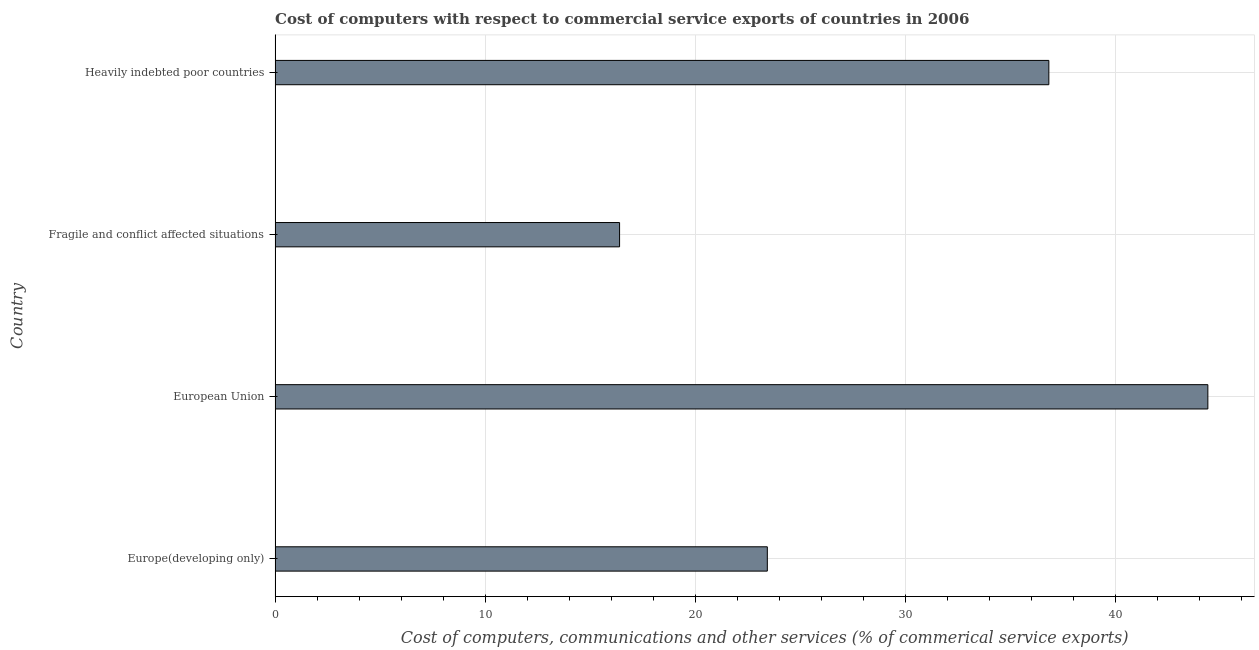What is the title of the graph?
Provide a short and direct response. Cost of computers with respect to commercial service exports of countries in 2006. What is the label or title of the X-axis?
Provide a succinct answer. Cost of computers, communications and other services (% of commerical service exports). What is the cost of communications in Fragile and conflict affected situations?
Offer a terse response. 16.39. Across all countries, what is the maximum cost of communications?
Offer a terse response. 44.38. Across all countries, what is the minimum cost of communications?
Offer a very short reply. 16.39. In which country was the  computer and other services minimum?
Make the answer very short. Fragile and conflict affected situations. What is the sum of the cost of communications?
Give a very brief answer. 121. What is the difference between the cost of communications in European Union and Fragile and conflict affected situations?
Keep it short and to the point. 27.99. What is the average  computer and other services per country?
Provide a short and direct response. 30.25. What is the median cost of communications?
Offer a terse response. 30.12. What is the ratio of the  computer and other services in Europe(developing only) to that in Fragile and conflict affected situations?
Offer a terse response. 1.43. Is the  computer and other services in European Union less than that in Heavily indebted poor countries?
Ensure brevity in your answer.  No. What is the difference between the highest and the second highest cost of communications?
Keep it short and to the point. 7.57. What is the difference between the highest and the lowest  computer and other services?
Ensure brevity in your answer.  27.99. In how many countries, is the cost of communications greater than the average cost of communications taken over all countries?
Provide a succinct answer. 2. How many bars are there?
Your answer should be compact. 4. Are all the bars in the graph horizontal?
Offer a terse response. Yes. What is the Cost of computers, communications and other services (% of commerical service exports) of Europe(developing only)?
Ensure brevity in your answer.  23.42. What is the Cost of computers, communications and other services (% of commerical service exports) of European Union?
Your response must be concise. 44.38. What is the Cost of computers, communications and other services (% of commerical service exports) of Fragile and conflict affected situations?
Give a very brief answer. 16.39. What is the Cost of computers, communications and other services (% of commerical service exports) of Heavily indebted poor countries?
Offer a very short reply. 36.81. What is the difference between the Cost of computers, communications and other services (% of commerical service exports) in Europe(developing only) and European Union?
Make the answer very short. -20.96. What is the difference between the Cost of computers, communications and other services (% of commerical service exports) in Europe(developing only) and Fragile and conflict affected situations?
Your answer should be very brief. 7.03. What is the difference between the Cost of computers, communications and other services (% of commerical service exports) in Europe(developing only) and Heavily indebted poor countries?
Your response must be concise. -13.39. What is the difference between the Cost of computers, communications and other services (% of commerical service exports) in European Union and Fragile and conflict affected situations?
Ensure brevity in your answer.  27.99. What is the difference between the Cost of computers, communications and other services (% of commerical service exports) in European Union and Heavily indebted poor countries?
Your answer should be very brief. 7.57. What is the difference between the Cost of computers, communications and other services (% of commerical service exports) in Fragile and conflict affected situations and Heavily indebted poor countries?
Your answer should be very brief. -20.42. What is the ratio of the Cost of computers, communications and other services (% of commerical service exports) in Europe(developing only) to that in European Union?
Your answer should be compact. 0.53. What is the ratio of the Cost of computers, communications and other services (% of commerical service exports) in Europe(developing only) to that in Fragile and conflict affected situations?
Ensure brevity in your answer.  1.43. What is the ratio of the Cost of computers, communications and other services (% of commerical service exports) in Europe(developing only) to that in Heavily indebted poor countries?
Provide a succinct answer. 0.64. What is the ratio of the Cost of computers, communications and other services (% of commerical service exports) in European Union to that in Fragile and conflict affected situations?
Offer a terse response. 2.71. What is the ratio of the Cost of computers, communications and other services (% of commerical service exports) in European Union to that in Heavily indebted poor countries?
Provide a short and direct response. 1.21. What is the ratio of the Cost of computers, communications and other services (% of commerical service exports) in Fragile and conflict affected situations to that in Heavily indebted poor countries?
Give a very brief answer. 0.45. 